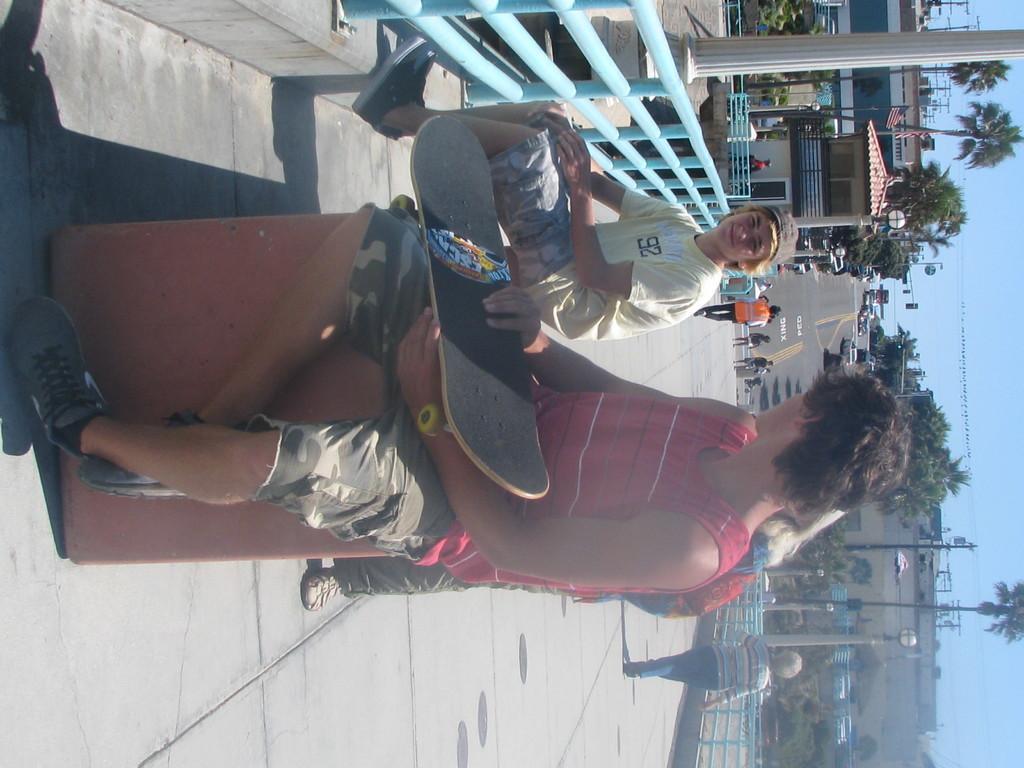Could you give a brief overview of what you see in this image? In this image we can see two men sitting on the floor and one of them is holding a skateboard in his hands. In the background we can see buildings, trees, flags, flag posts, pillars, grill, persons, electric poles, street poles, street lights and sky. 